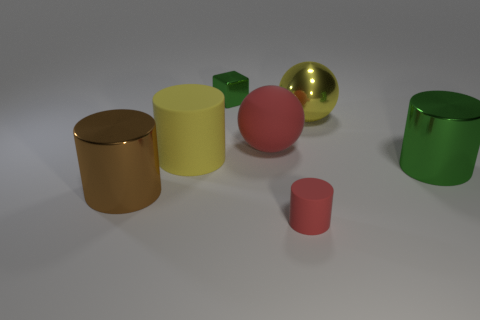Add 3 brown objects. How many objects exist? 10 Subtract all blocks. How many objects are left? 6 Subtract 1 green cylinders. How many objects are left? 6 Subtract all rubber things. Subtract all small metal things. How many objects are left? 3 Add 5 small green shiny cubes. How many small green shiny cubes are left? 6 Add 4 big red rubber blocks. How many big red rubber blocks exist? 4 